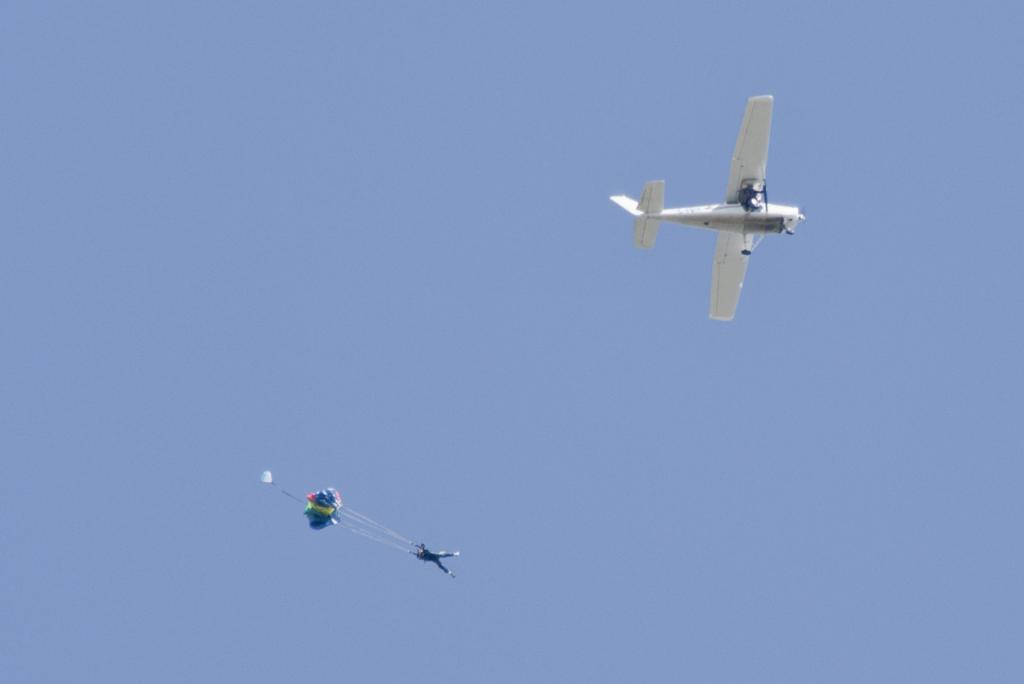What is happening in the sky in the image? There is a flight in the air in the image. Can you describe any other activities happening in the sky? A person is paragliding beside the flight. What type of mist can be seen surrounding the queen and her ball in the image? There is no queen, ball, or mist present in the image; it features a flight and a person paragliding. 